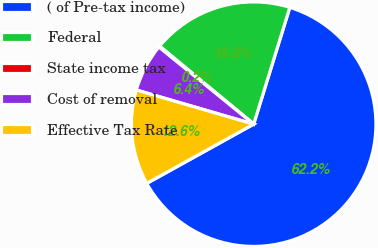<chart> <loc_0><loc_0><loc_500><loc_500><pie_chart><fcel>( of Pre-tax income)<fcel>Federal<fcel>State income tax<fcel>Cost of removal<fcel>Effective Tax Rate<nl><fcel>62.17%<fcel>18.76%<fcel>0.15%<fcel>6.36%<fcel>12.56%<nl></chart> 